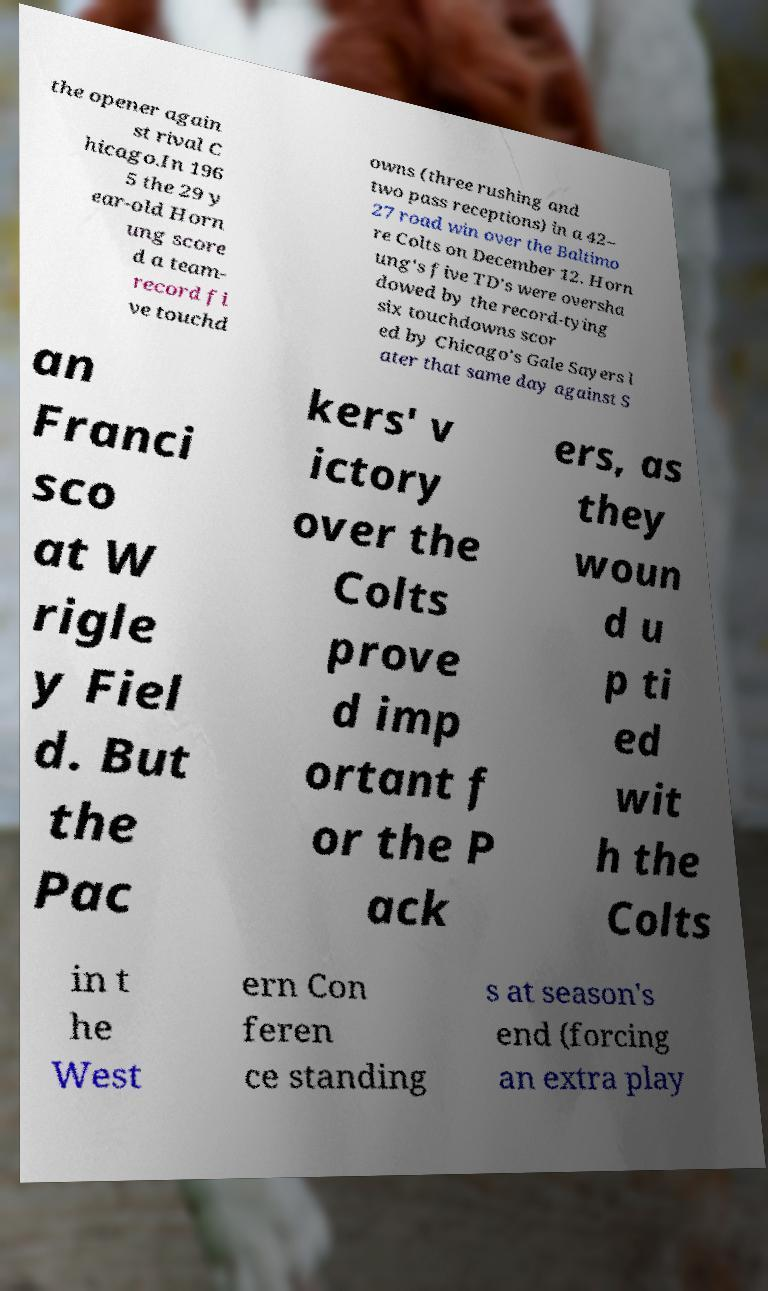Can you read and provide the text displayed in the image?This photo seems to have some interesting text. Can you extract and type it out for me? the opener again st rival C hicago.In 196 5 the 29 y ear-old Horn ung score d a team- record fi ve touchd owns (three rushing and two pass receptions) in a 42– 27 road win over the Baltimo re Colts on December 12. Horn ung's five TD's were oversha dowed by the record-tying six touchdowns scor ed by Chicago's Gale Sayers l ater that same day against S an Franci sco at W rigle y Fiel d. But the Pac kers' v ictory over the Colts prove d imp ortant f or the P ack ers, as they woun d u p ti ed wit h the Colts in t he West ern Con feren ce standing s at season's end (forcing an extra play 